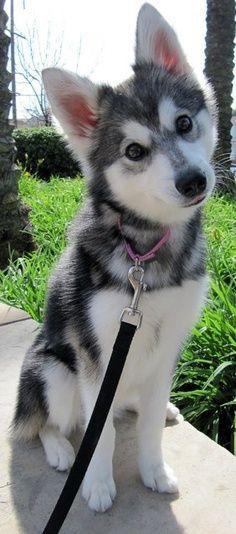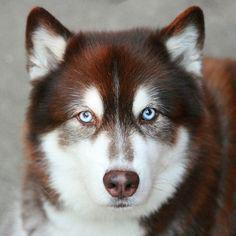The first image is the image on the left, the second image is the image on the right. For the images displayed, is the sentence "Three or more mammals are visible." factually correct? Answer yes or no. No. The first image is the image on the left, the second image is the image on the right. Assess this claim about the two images: "One of the dogs is brown and white.". Correct or not? Answer yes or no. Yes. 